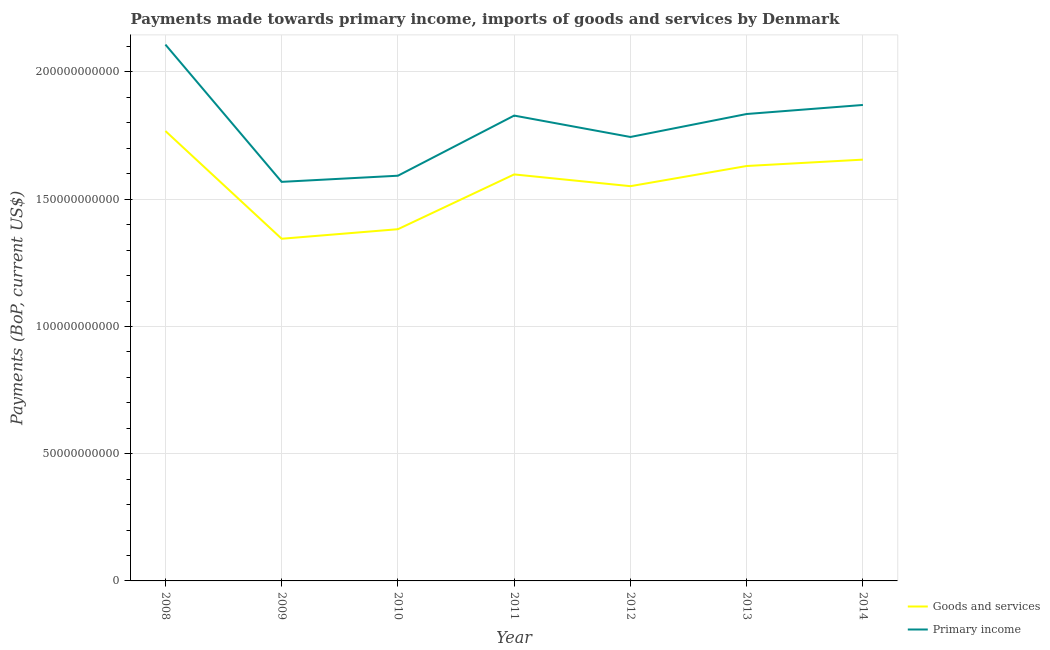How many different coloured lines are there?
Your answer should be very brief. 2. Does the line corresponding to payments made towards primary income intersect with the line corresponding to payments made towards goods and services?
Offer a very short reply. No. What is the payments made towards goods and services in 2008?
Your response must be concise. 1.77e+11. Across all years, what is the maximum payments made towards goods and services?
Offer a very short reply. 1.77e+11. Across all years, what is the minimum payments made towards goods and services?
Offer a very short reply. 1.34e+11. In which year was the payments made towards primary income minimum?
Keep it short and to the point. 2009. What is the total payments made towards goods and services in the graph?
Make the answer very short. 1.09e+12. What is the difference between the payments made towards primary income in 2008 and that in 2009?
Your answer should be very brief. 5.39e+1. What is the difference between the payments made towards primary income in 2012 and the payments made towards goods and services in 2010?
Offer a terse response. 3.62e+1. What is the average payments made towards primary income per year?
Your answer should be very brief. 1.79e+11. In the year 2013, what is the difference between the payments made towards goods and services and payments made towards primary income?
Give a very brief answer. -2.04e+1. In how many years, is the payments made towards primary income greater than 60000000000 US$?
Offer a terse response. 7. What is the ratio of the payments made towards primary income in 2008 to that in 2010?
Make the answer very short. 1.32. Is the payments made towards primary income in 2011 less than that in 2014?
Keep it short and to the point. Yes. Is the difference between the payments made towards primary income in 2012 and 2014 greater than the difference between the payments made towards goods and services in 2012 and 2014?
Provide a short and direct response. No. What is the difference between the highest and the second highest payments made towards primary income?
Ensure brevity in your answer.  2.37e+1. What is the difference between the highest and the lowest payments made towards goods and services?
Your response must be concise. 4.23e+1. In how many years, is the payments made towards primary income greater than the average payments made towards primary income taken over all years?
Provide a succinct answer. 4. Is the payments made towards primary income strictly greater than the payments made towards goods and services over the years?
Give a very brief answer. Yes. Is the payments made towards goods and services strictly less than the payments made towards primary income over the years?
Keep it short and to the point. Yes. How many lines are there?
Offer a terse response. 2. How many years are there in the graph?
Offer a terse response. 7. What is the difference between two consecutive major ticks on the Y-axis?
Keep it short and to the point. 5.00e+1. Are the values on the major ticks of Y-axis written in scientific E-notation?
Your response must be concise. No. Does the graph contain any zero values?
Make the answer very short. No. Where does the legend appear in the graph?
Keep it short and to the point. Bottom right. How many legend labels are there?
Give a very brief answer. 2. What is the title of the graph?
Provide a short and direct response. Payments made towards primary income, imports of goods and services by Denmark. Does "Methane emissions" appear as one of the legend labels in the graph?
Give a very brief answer. No. What is the label or title of the Y-axis?
Provide a succinct answer. Payments (BoP, current US$). What is the Payments (BoP, current US$) in Goods and services in 2008?
Provide a succinct answer. 1.77e+11. What is the Payments (BoP, current US$) of Primary income in 2008?
Make the answer very short. 2.11e+11. What is the Payments (BoP, current US$) in Goods and services in 2009?
Offer a terse response. 1.34e+11. What is the Payments (BoP, current US$) of Primary income in 2009?
Give a very brief answer. 1.57e+11. What is the Payments (BoP, current US$) in Goods and services in 2010?
Offer a very short reply. 1.38e+11. What is the Payments (BoP, current US$) of Primary income in 2010?
Offer a terse response. 1.59e+11. What is the Payments (BoP, current US$) of Goods and services in 2011?
Offer a very short reply. 1.60e+11. What is the Payments (BoP, current US$) of Primary income in 2011?
Give a very brief answer. 1.83e+11. What is the Payments (BoP, current US$) of Goods and services in 2012?
Make the answer very short. 1.55e+11. What is the Payments (BoP, current US$) in Primary income in 2012?
Offer a very short reply. 1.74e+11. What is the Payments (BoP, current US$) of Goods and services in 2013?
Make the answer very short. 1.63e+11. What is the Payments (BoP, current US$) of Primary income in 2013?
Make the answer very short. 1.83e+11. What is the Payments (BoP, current US$) in Goods and services in 2014?
Give a very brief answer. 1.66e+11. What is the Payments (BoP, current US$) of Primary income in 2014?
Your answer should be very brief. 1.87e+11. Across all years, what is the maximum Payments (BoP, current US$) of Goods and services?
Provide a succinct answer. 1.77e+11. Across all years, what is the maximum Payments (BoP, current US$) of Primary income?
Give a very brief answer. 2.11e+11. Across all years, what is the minimum Payments (BoP, current US$) in Goods and services?
Provide a short and direct response. 1.34e+11. Across all years, what is the minimum Payments (BoP, current US$) of Primary income?
Ensure brevity in your answer.  1.57e+11. What is the total Payments (BoP, current US$) of Goods and services in the graph?
Provide a succinct answer. 1.09e+12. What is the total Payments (BoP, current US$) in Primary income in the graph?
Keep it short and to the point. 1.25e+12. What is the difference between the Payments (BoP, current US$) of Goods and services in 2008 and that in 2009?
Offer a terse response. 4.23e+1. What is the difference between the Payments (BoP, current US$) in Primary income in 2008 and that in 2009?
Your response must be concise. 5.39e+1. What is the difference between the Payments (BoP, current US$) of Goods and services in 2008 and that in 2010?
Ensure brevity in your answer.  3.86e+1. What is the difference between the Payments (BoP, current US$) of Primary income in 2008 and that in 2010?
Provide a short and direct response. 5.15e+1. What is the difference between the Payments (BoP, current US$) of Goods and services in 2008 and that in 2011?
Ensure brevity in your answer.  1.71e+1. What is the difference between the Payments (BoP, current US$) of Primary income in 2008 and that in 2011?
Your answer should be very brief. 2.79e+1. What is the difference between the Payments (BoP, current US$) in Goods and services in 2008 and that in 2012?
Offer a very short reply. 2.17e+1. What is the difference between the Payments (BoP, current US$) in Primary income in 2008 and that in 2012?
Offer a very short reply. 3.63e+1. What is the difference between the Payments (BoP, current US$) in Goods and services in 2008 and that in 2013?
Your answer should be compact. 1.38e+1. What is the difference between the Payments (BoP, current US$) in Primary income in 2008 and that in 2013?
Offer a very short reply. 2.73e+1. What is the difference between the Payments (BoP, current US$) of Goods and services in 2008 and that in 2014?
Keep it short and to the point. 1.13e+1. What is the difference between the Payments (BoP, current US$) in Primary income in 2008 and that in 2014?
Your answer should be very brief. 2.37e+1. What is the difference between the Payments (BoP, current US$) of Goods and services in 2009 and that in 2010?
Your answer should be very brief. -3.75e+09. What is the difference between the Payments (BoP, current US$) in Primary income in 2009 and that in 2010?
Make the answer very short. -2.42e+09. What is the difference between the Payments (BoP, current US$) in Goods and services in 2009 and that in 2011?
Provide a succinct answer. -2.53e+1. What is the difference between the Payments (BoP, current US$) in Primary income in 2009 and that in 2011?
Provide a short and direct response. -2.60e+1. What is the difference between the Payments (BoP, current US$) of Goods and services in 2009 and that in 2012?
Make the answer very short. -2.07e+1. What is the difference between the Payments (BoP, current US$) in Primary income in 2009 and that in 2012?
Offer a very short reply. -1.76e+1. What is the difference between the Payments (BoP, current US$) in Goods and services in 2009 and that in 2013?
Your response must be concise. -2.86e+1. What is the difference between the Payments (BoP, current US$) of Primary income in 2009 and that in 2013?
Your response must be concise. -2.67e+1. What is the difference between the Payments (BoP, current US$) of Goods and services in 2009 and that in 2014?
Your response must be concise. -3.11e+1. What is the difference between the Payments (BoP, current US$) of Primary income in 2009 and that in 2014?
Provide a succinct answer. -3.02e+1. What is the difference between the Payments (BoP, current US$) of Goods and services in 2010 and that in 2011?
Your answer should be compact. -2.15e+1. What is the difference between the Payments (BoP, current US$) in Primary income in 2010 and that in 2011?
Offer a very short reply. -2.36e+1. What is the difference between the Payments (BoP, current US$) in Goods and services in 2010 and that in 2012?
Keep it short and to the point. -1.69e+1. What is the difference between the Payments (BoP, current US$) of Primary income in 2010 and that in 2012?
Provide a short and direct response. -1.52e+1. What is the difference between the Payments (BoP, current US$) in Goods and services in 2010 and that in 2013?
Give a very brief answer. -2.48e+1. What is the difference between the Payments (BoP, current US$) of Primary income in 2010 and that in 2013?
Offer a very short reply. -2.43e+1. What is the difference between the Payments (BoP, current US$) of Goods and services in 2010 and that in 2014?
Provide a short and direct response. -2.73e+1. What is the difference between the Payments (BoP, current US$) in Primary income in 2010 and that in 2014?
Offer a terse response. -2.78e+1. What is the difference between the Payments (BoP, current US$) in Goods and services in 2011 and that in 2012?
Give a very brief answer. 4.62e+09. What is the difference between the Payments (BoP, current US$) in Primary income in 2011 and that in 2012?
Your answer should be compact. 8.41e+09. What is the difference between the Payments (BoP, current US$) of Goods and services in 2011 and that in 2013?
Your answer should be compact. -3.31e+09. What is the difference between the Payments (BoP, current US$) in Primary income in 2011 and that in 2013?
Ensure brevity in your answer.  -6.19e+08. What is the difference between the Payments (BoP, current US$) of Goods and services in 2011 and that in 2014?
Give a very brief answer. -5.81e+09. What is the difference between the Payments (BoP, current US$) of Primary income in 2011 and that in 2014?
Provide a short and direct response. -4.17e+09. What is the difference between the Payments (BoP, current US$) of Goods and services in 2012 and that in 2013?
Provide a short and direct response. -7.93e+09. What is the difference between the Payments (BoP, current US$) in Primary income in 2012 and that in 2013?
Offer a terse response. -9.03e+09. What is the difference between the Payments (BoP, current US$) in Goods and services in 2012 and that in 2014?
Your answer should be compact. -1.04e+1. What is the difference between the Payments (BoP, current US$) in Primary income in 2012 and that in 2014?
Your answer should be very brief. -1.26e+1. What is the difference between the Payments (BoP, current US$) in Goods and services in 2013 and that in 2014?
Make the answer very short. -2.50e+09. What is the difference between the Payments (BoP, current US$) in Primary income in 2013 and that in 2014?
Ensure brevity in your answer.  -3.55e+09. What is the difference between the Payments (BoP, current US$) in Goods and services in 2008 and the Payments (BoP, current US$) in Primary income in 2009?
Your answer should be compact. 2.00e+1. What is the difference between the Payments (BoP, current US$) of Goods and services in 2008 and the Payments (BoP, current US$) of Primary income in 2010?
Provide a succinct answer. 1.76e+1. What is the difference between the Payments (BoP, current US$) of Goods and services in 2008 and the Payments (BoP, current US$) of Primary income in 2011?
Your response must be concise. -6.06e+09. What is the difference between the Payments (BoP, current US$) in Goods and services in 2008 and the Payments (BoP, current US$) in Primary income in 2012?
Your answer should be very brief. 2.35e+09. What is the difference between the Payments (BoP, current US$) of Goods and services in 2008 and the Payments (BoP, current US$) of Primary income in 2013?
Your answer should be compact. -6.68e+09. What is the difference between the Payments (BoP, current US$) of Goods and services in 2008 and the Payments (BoP, current US$) of Primary income in 2014?
Make the answer very short. -1.02e+1. What is the difference between the Payments (BoP, current US$) of Goods and services in 2009 and the Payments (BoP, current US$) of Primary income in 2010?
Your response must be concise. -2.48e+1. What is the difference between the Payments (BoP, current US$) in Goods and services in 2009 and the Payments (BoP, current US$) in Primary income in 2011?
Make the answer very short. -4.84e+1. What is the difference between the Payments (BoP, current US$) of Goods and services in 2009 and the Payments (BoP, current US$) of Primary income in 2012?
Your answer should be very brief. -4.00e+1. What is the difference between the Payments (BoP, current US$) of Goods and services in 2009 and the Payments (BoP, current US$) of Primary income in 2013?
Your answer should be very brief. -4.90e+1. What is the difference between the Payments (BoP, current US$) in Goods and services in 2009 and the Payments (BoP, current US$) in Primary income in 2014?
Offer a very short reply. -5.26e+1. What is the difference between the Payments (BoP, current US$) in Goods and services in 2010 and the Payments (BoP, current US$) in Primary income in 2011?
Provide a short and direct response. -4.47e+1. What is the difference between the Payments (BoP, current US$) of Goods and services in 2010 and the Payments (BoP, current US$) of Primary income in 2012?
Provide a succinct answer. -3.62e+1. What is the difference between the Payments (BoP, current US$) in Goods and services in 2010 and the Payments (BoP, current US$) in Primary income in 2013?
Ensure brevity in your answer.  -4.53e+1. What is the difference between the Payments (BoP, current US$) in Goods and services in 2010 and the Payments (BoP, current US$) in Primary income in 2014?
Keep it short and to the point. -4.88e+1. What is the difference between the Payments (BoP, current US$) of Goods and services in 2011 and the Payments (BoP, current US$) of Primary income in 2012?
Your response must be concise. -1.47e+1. What is the difference between the Payments (BoP, current US$) of Goods and services in 2011 and the Payments (BoP, current US$) of Primary income in 2013?
Ensure brevity in your answer.  -2.37e+1. What is the difference between the Payments (BoP, current US$) of Goods and services in 2011 and the Payments (BoP, current US$) of Primary income in 2014?
Your answer should be compact. -2.73e+1. What is the difference between the Payments (BoP, current US$) of Goods and services in 2012 and the Payments (BoP, current US$) of Primary income in 2013?
Ensure brevity in your answer.  -2.84e+1. What is the difference between the Payments (BoP, current US$) of Goods and services in 2012 and the Payments (BoP, current US$) of Primary income in 2014?
Make the answer very short. -3.19e+1. What is the difference between the Payments (BoP, current US$) of Goods and services in 2013 and the Payments (BoP, current US$) of Primary income in 2014?
Give a very brief answer. -2.40e+1. What is the average Payments (BoP, current US$) of Goods and services per year?
Keep it short and to the point. 1.56e+11. What is the average Payments (BoP, current US$) in Primary income per year?
Ensure brevity in your answer.  1.79e+11. In the year 2008, what is the difference between the Payments (BoP, current US$) in Goods and services and Payments (BoP, current US$) in Primary income?
Offer a very short reply. -3.40e+1. In the year 2009, what is the difference between the Payments (BoP, current US$) in Goods and services and Payments (BoP, current US$) in Primary income?
Provide a short and direct response. -2.24e+1. In the year 2010, what is the difference between the Payments (BoP, current US$) of Goods and services and Payments (BoP, current US$) of Primary income?
Offer a very short reply. -2.10e+1. In the year 2011, what is the difference between the Payments (BoP, current US$) of Goods and services and Payments (BoP, current US$) of Primary income?
Offer a very short reply. -2.31e+1. In the year 2012, what is the difference between the Payments (BoP, current US$) of Goods and services and Payments (BoP, current US$) of Primary income?
Keep it short and to the point. -1.93e+1. In the year 2013, what is the difference between the Payments (BoP, current US$) in Goods and services and Payments (BoP, current US$) in Primary income?
Offer a terse response. -2.04e+1. In the year 2014, what is the difference between the Payments (BoP, current US$) of Goods and services and Payments (BoP, current US$) of Primary income?
Ensure brevity in your answer.  -2.15e+1. What is the ratio of the Payments (BoP, current US$) of Goods and services in 2008 to that in 2009?
Your answer should be compact. 1.31. What is the ratio of the Payments (BoP, current US$) in Primary income in 2008 to that in 2009?
Ensure brevity in your answer.  1.34. What is the ratio of the Payments (BoP, current US$) in Goods and services in 2008 to that in 2010?
Offer a very short reply. 1.28. What is the ratio of the Payments (BoP, current US$) in Primary income in 2008 to that in 2010?
Give a very brief answer. 1.32. What is the ratio of the Payments (BoP, current US$) in Goods and services in 2008 to that in 2011?
Your answer should be compact. 1.11. What is the ratio of the Payments (BoP, current US$) in Primary income in 2008 to that in 2011?
Make the answer very short. 1.15. What is the ratio of the Payments (BoP, current US$) in Goods and services in 2008 to that in 2012?
Provide a short and direct response. 1.14. What is the ratio of the Payments (BoP, current US$) of Primary income in 2008 to that in 2012?
Make the answer very short. 1.21. What is the ratio of the Payments (BoP, current US$) of Goods and services in 2008 to that in 2013?
Provide a short and direct response. 1.08. What is the ratio of the Payments (BoP, current US$) of Primary income in 2008 to that in 2013?
Your response must be concise. 1.15. What is the ratio of the Payments (BoP, current US$) of Goods and services in 2008 to that in 2014?
Offer a terse response. 1.07. What is the ratio of the Payments (BoP, current US$) in Primary income in 2008 to that in 2014?
Offer a very short reply. 1.13. What is the ratio of the Payments (BoP, current US$) in Goods and services in 2009 to that in 2010?
Offer a terse response. 0.97. What is the ratio of the Payments (BoP, current US$) in Goods and services in 2009 to that in 2011?
Your answer should be compact. 0.84. What is the ratio of the Payments (BoP, current US$) of Primary income in 2009 to that in 2011?
Provide a succinct answer. 0.86. What is the ratio of the Payments (BoP, current US$) in Goods and services in 2009 to that in 2012?
Ensure brevity in your answer.  0.87. What is the ratio of the Payments (BoP, current US$) of Primary income in 2009 to that in 2012?
Give a very brief answer. 0.9. What is the ratio of the Payments (BoP, current US$) in Goods and services in 2009 to that in 2013?
Keep it short and to the point. 0.82. What is the ratio of the Payments (BoP, current US$) of Primary income in 2009 to that in 2013?
Offer a terse response. 0.85. What is the ratio of the Payments (BoP, current US$) in Goods and services in 2009 to that in 2014?
Ensure brevity in your answer.  0.81. What is the ratio of the Payments (BoP, current US$) of Primary income in 2009 to that in 2014?
Ensure brevity in your answer.  0.84. What is the ratio of the Payments (BoP, current US$) of Goods and services in 2010 to that in 2011?
Provide a short and direct response. 0.87. What is the ratio of the Payments (BoP, current US$) of Primary income in 2010 to that in 2011?
Provide a short and direct response. 0.87. What is the ratio of the Payments (BoP, current US$) in Goods and services in 2010 to that in 2012?
Your answer should be compact. 0.89. What is the ratio of the Payments (BoP, current US$) of Primary income in 2010 to that in 2012?
Provide a short and direct response. 0.91. What is the ratio of the Payments (BoP, current US$) of Goods and services in 2010 to that in 2013?
Give a very brief answer. 0.85. What is the ratio of the Payments (BoP, current US$) in Primary income in 2010 to that in 2013?
Provide a succinct answer. 0.87. What is the ratio of the Payments (BoP, current US$) of Goods and services in 2010 to that in 2014?
Offer a terse response. 0.83. What is the ratio of the Payments (BoP, current US$) in Primary income in 2010 to that in 2014?
Your answer should be very brief. 0.85. What is the ratio of the Payments (BoP, current US$) in Goods and services in 2011 to that in 2012?
Offer a terse response. 1.03. What is the ratio of the Payments (BoP, current US$) of Primary income in 2011 to that in 2012?
Your answer should be compact. 1.05. What is the ratio of the Payments (BoP, current US$) of Goods and services in 2011 to that in 2013?
Your response must be concise. 0.98. What is the ratio of the Payments (BoP, current US$) in Primary income in 2011 to that in 2013?
Ensure brevity in your answer.  1. What is the ratio of the Payments (BoP, current US$) in Goods and services in 2011 to that in 2014?
Offer a very short reply. 0.96. What is the ratio of the Payments (BoP, current US$) of Primary income in 2011 to that in 2014?
Your answer should be compact. 0.98. What is the ratio of the Payments (BoP, current US$) in Goods and services in 2012 to that in 2013?
Keep it short and to the point. 0.95. What is the ratio of the Payments (BoP, current US$) in Primary income in 2012 to that in 2013?
Your response must be concise. 0.95. What is the ratio of the Payments (BoP, current US$) in Goods and services in 2012 to that in 2014?
Provide a short and direct response. 0.94. What is the ratio of the Payments (BoP, current US$) in Primary income in 2012 to that in 2014?
Keep it short and to the point. 0.93. What is the ratio of the Payments (BoP, current US$) in Goods and services in 2013 to that in 2014?
Provide a succinct answer. 0.98. What is the ratio of the Payments (BoP, current US$) in Primary income in 2013 to that in 2014?
Your answer should be very brief. 0.98. What is the difference between the highest and the second highest Payments (BoP, current US$) in Goods and services?
Keep it short and to the point. 1.13e+1. What is the difference between the highest and the second highest Payments (BoP, current US$) in Primary income?
Provide a short and direct response. 2.37e+1. What is the difference between the highest and the lowest Payments (BoP, current US$) of Goods and services?
Make the answer very short. 4.23e+1. What is the difference between the highest and the lowest Payments (BoP, current US$) in Primary income?
Make the answer very short. 5.39e+1. 